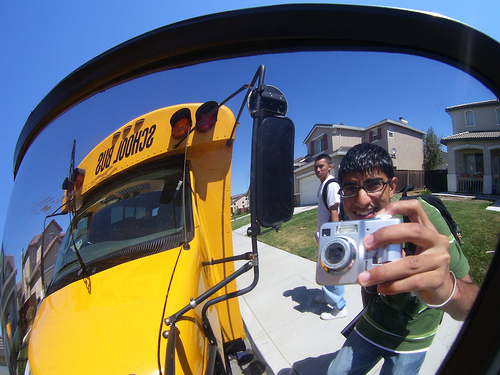Please provide the bounding box coordinate of the region this sentence describes: a hand holding a camera. The bounding box for the region described by 'a hand holding a camera' is [0.61, 0.54, 0.9, 0.73]. 